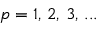Convert formula to latex. <formula><loc_0><loc_0><loc_500><loc_500>p = 1 , \, 2 , \, 3 , \, \dots</formula> 